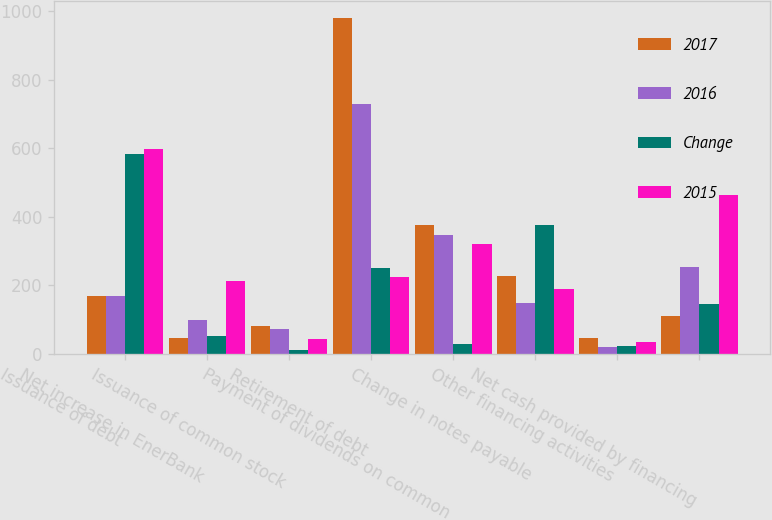Convert chart to OTSL. <chart><loc_0><loc_0><loc_500><loc_500><stacked_bar_chart><ecel><fcel>Issuance of debt<fcel>Net increase in EnerBank<fcel>Issuance of common stock<fcel>Retirement of debt<fcel>Payment of dividends on common<fcel>Change in notes payable<fcel>Other financing activities<fcel>Net cash provided by financing<nl><fcel>2017<fcel>169<fcel>47<fcel>83<fcel>980<fcel>377<fcel>228<fcel>46<fcel>110<nl><fcel>2016<fcel>169<fcel>100<fcel>72<fcel>728<fcel>347<fcel>149<fcel>22<fcel>255<nl><fcel>Change<fcel>584<fcel>53<fcel>11<fcel>252<fcel>30<fcel>377<fcel>24<fcel>145<nl><fcel>2015<fcel>599<fcel>214<fcel>43<fcel>224<fcel>322<fcel>189<fcel>36<fcel>463<nl></chart> 